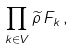<formula> <loc_0><loc_0><loc_500><loc_500>\prod _ { k \in V } \widetilde { \rho } \, F _ { k } \, ,</formula> 